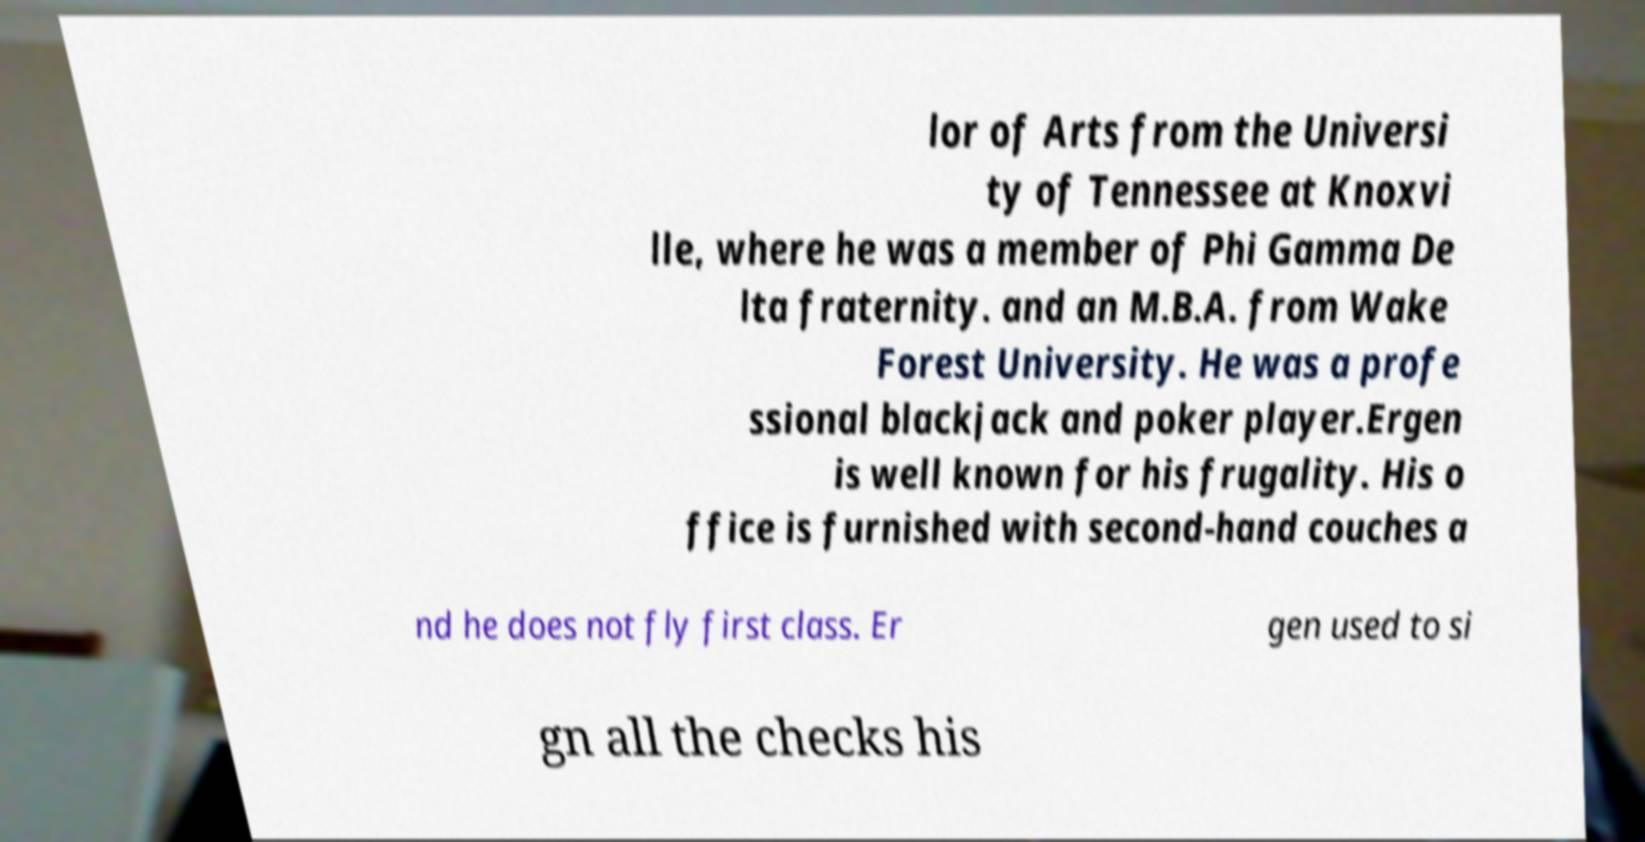What messages or text are displayed in this image? I need them in a readable, typed format. lor of Arts from the Universi ty of Tennessee at Knoxvi lle, where he was a member of Phi Gamma De lta fraternity. and an M.B.A. from Wake Forest University. He was a profe ssional blackjack and poker player.Ergen is well known for his frugality. His o ffice is furnished with second-hand couches a nd he does not fly first class. Er gen used to si gn all the checks his 